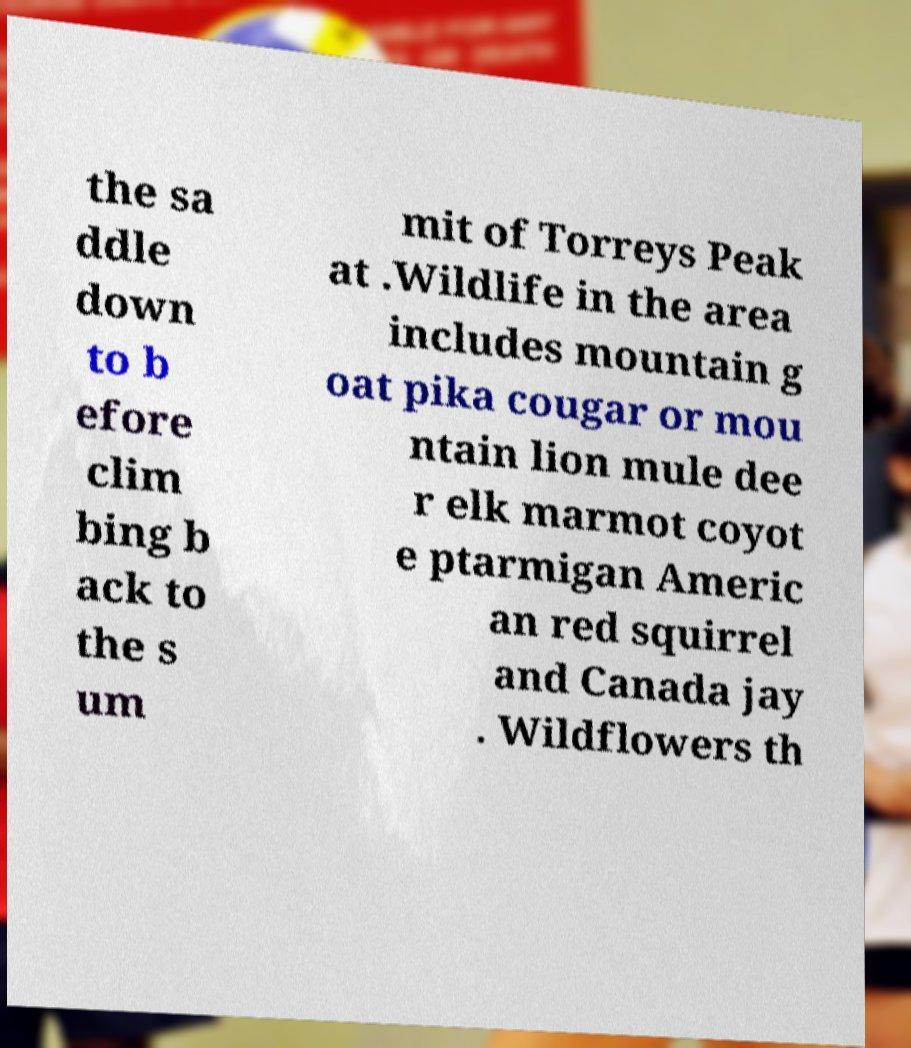What messages or text are displayed in this image? I need them in a readable, typed format. the sa ddle down to b efore clim bing b ack to the s um mit of Torreys Peak at .Wildlife in the area includes mountain g oat pika cougar or mou ntain lion mule dee r elk marmot coyot e ptarmigan Americ an red squirrel and Canada jay . Wildflowers th 